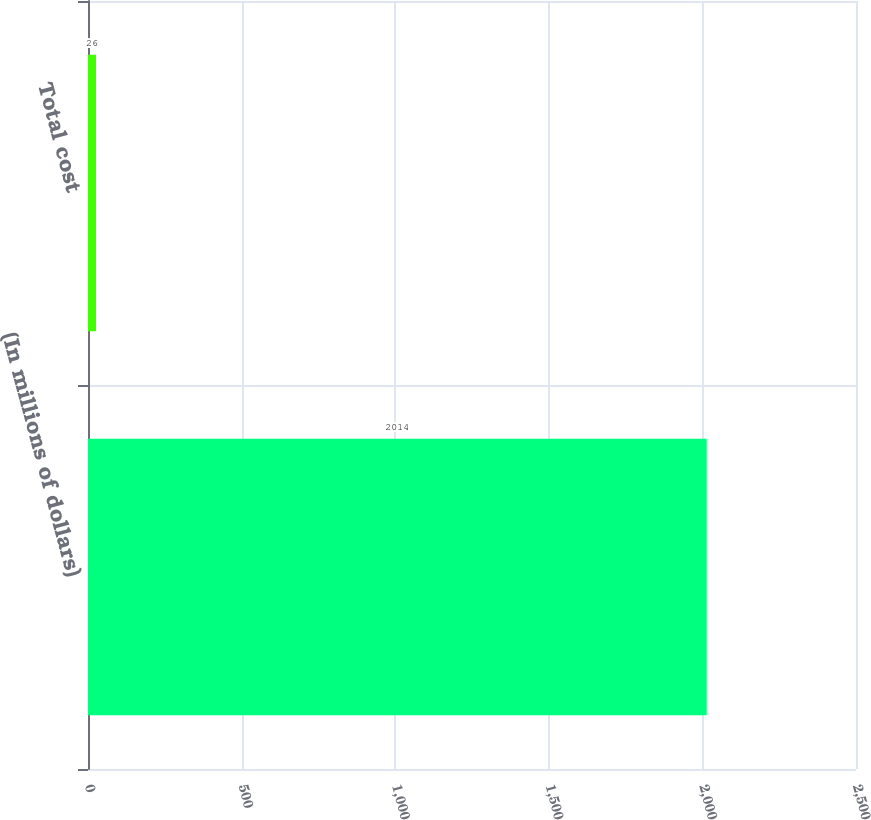<chart> <loc_0><loc_0><loc_500><loc_500><bar_chart><fcel>(In millions of dollars)<fcel>Total cost<nl><fcel>2014<fcel>26<nl></chart> 